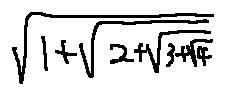Convert formula to latex. <formula><loc_0><loc_0><loc_500><loc_500>\sqrt { 1 + \sqrt { 2 + \sqrt { 3 + \sqrt { 4 } } } }</formula> 